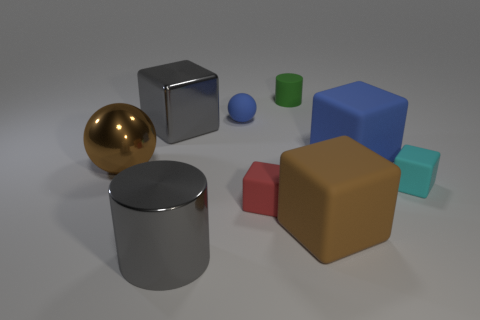Subtract all large blue matte cubes. How many cubes are left? 4 Subtract all brown blocks. How many blocks are left? 4 Subtract all green blocks. Subtract all cyan spheres. How many blocks are left? 5 Add 1 green rubber objects. How many objects exist? 10 Subtract all cubes. How many objects are left? 4 Add 4 large objects. How many large objects exist? 9 Subtract 1 blue blocks. How many objects are left? 8 Subtract all small green matte objects. Subtract all large yellow objects. How many objects are left? 8 Add 4 gray metallic cylinders. How many gray metallic cylinders are left? 5 